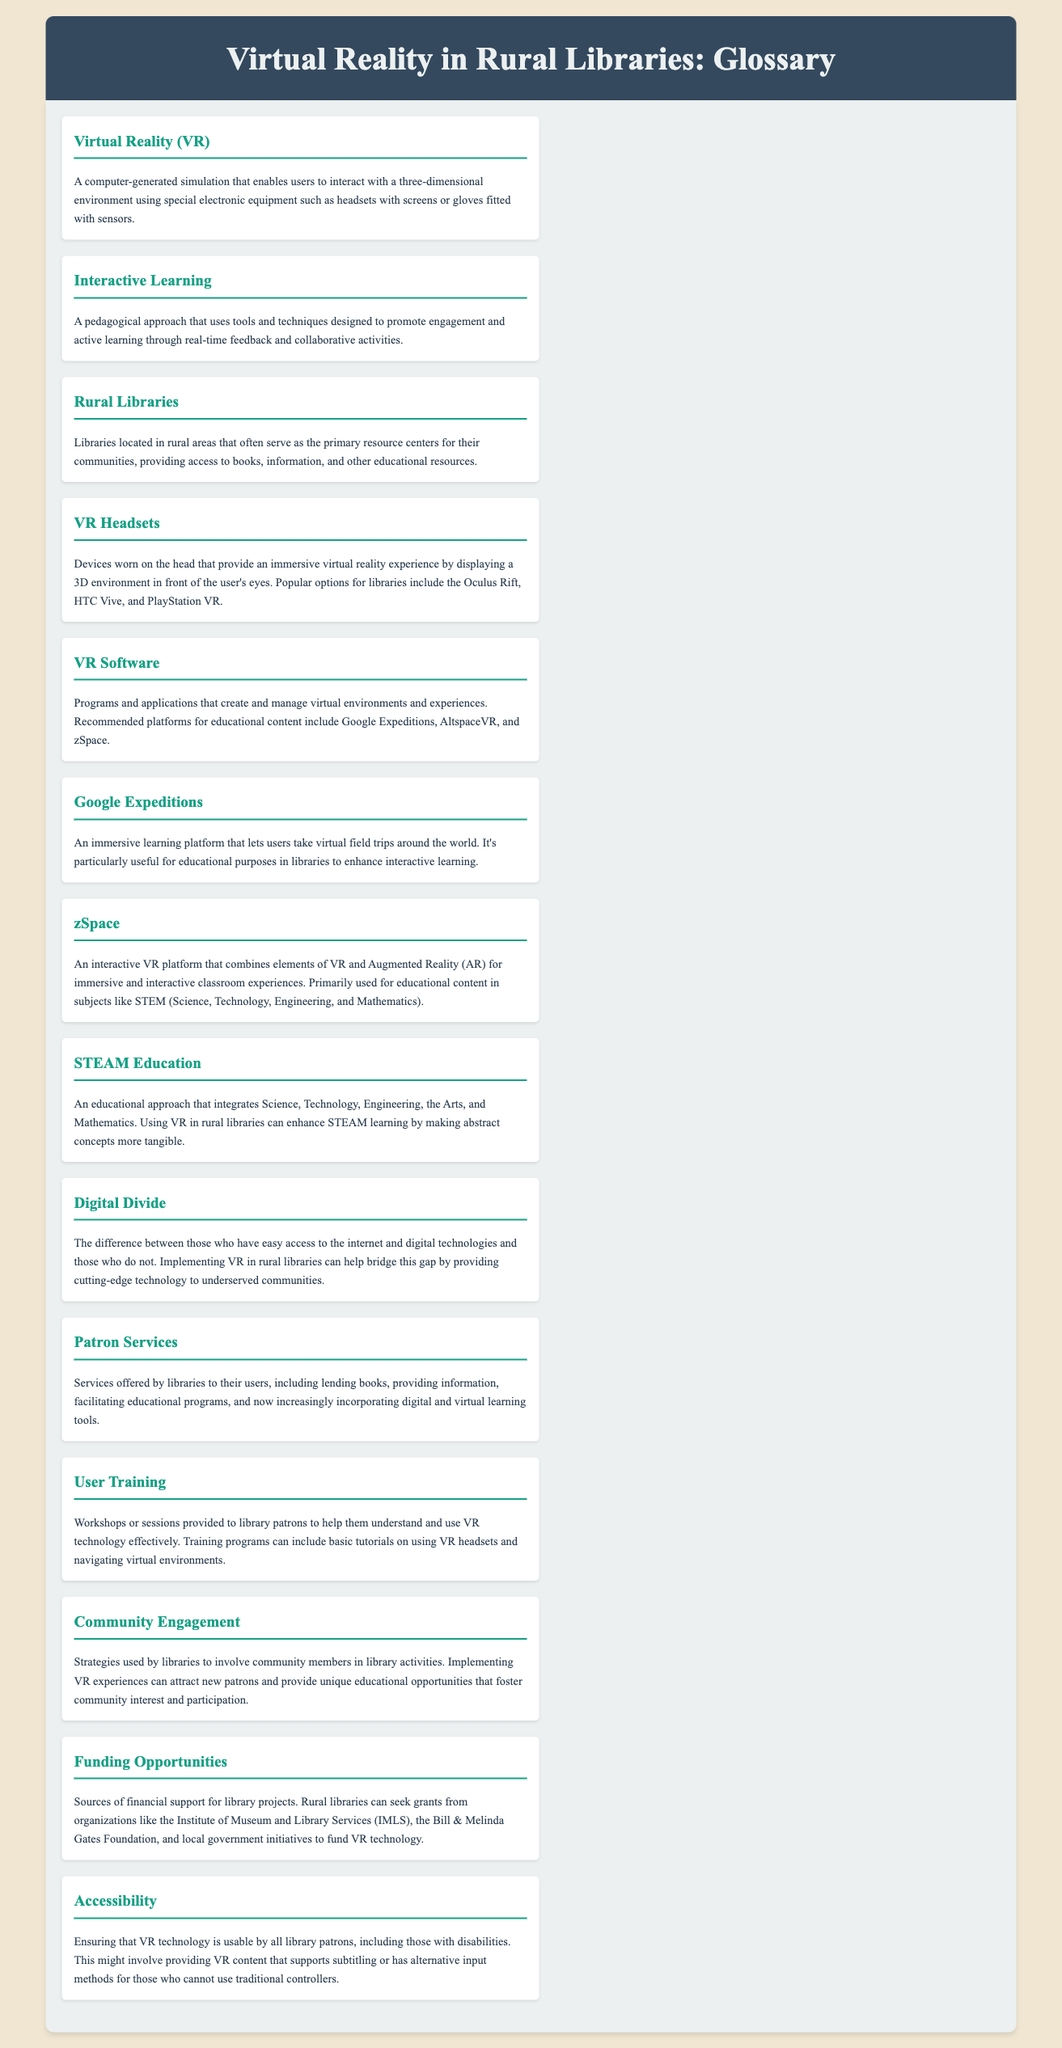What does VR stand for? The acronym 'VR' is defined in the glossary section of the document.
Answer: Virtual Reality What are VR headsets used for? The glossary describes the purpose of VR headsets in the context of virtual reality.
Answer: Immersive virtual reality experience What is the purpose of Google Expeditions? The description of Google Expeditions in the glossary explains its main function.
Answer: Virtual field trips What is zSpace primarily used for? The document specifies the subject area that zSpace focuses on for educational content.
Answer: STEM What is one major challenge addressed in the document? The glossary mentions a significant issue that rural libraries face regarding technology access.
Answer: Digital Divide How can VR enhance education according to the glossary? The document suggests a broad educational approach that VR supports.
Answer: STEAM Education What is an essential component of community engagement mentioned? Community engagement is discussed regarding unique educational opportunities.
Answer: VR experiences Which organization is mentioned as a funding source? The glossary points out specific sources of grants and support for library projects.
Answer: Institute of Museum and Library Services What do user training programs help with? The glossary outlines what user training sessions aim to achieve for library patrons.
Answer: Understand and use VR technology effectively 